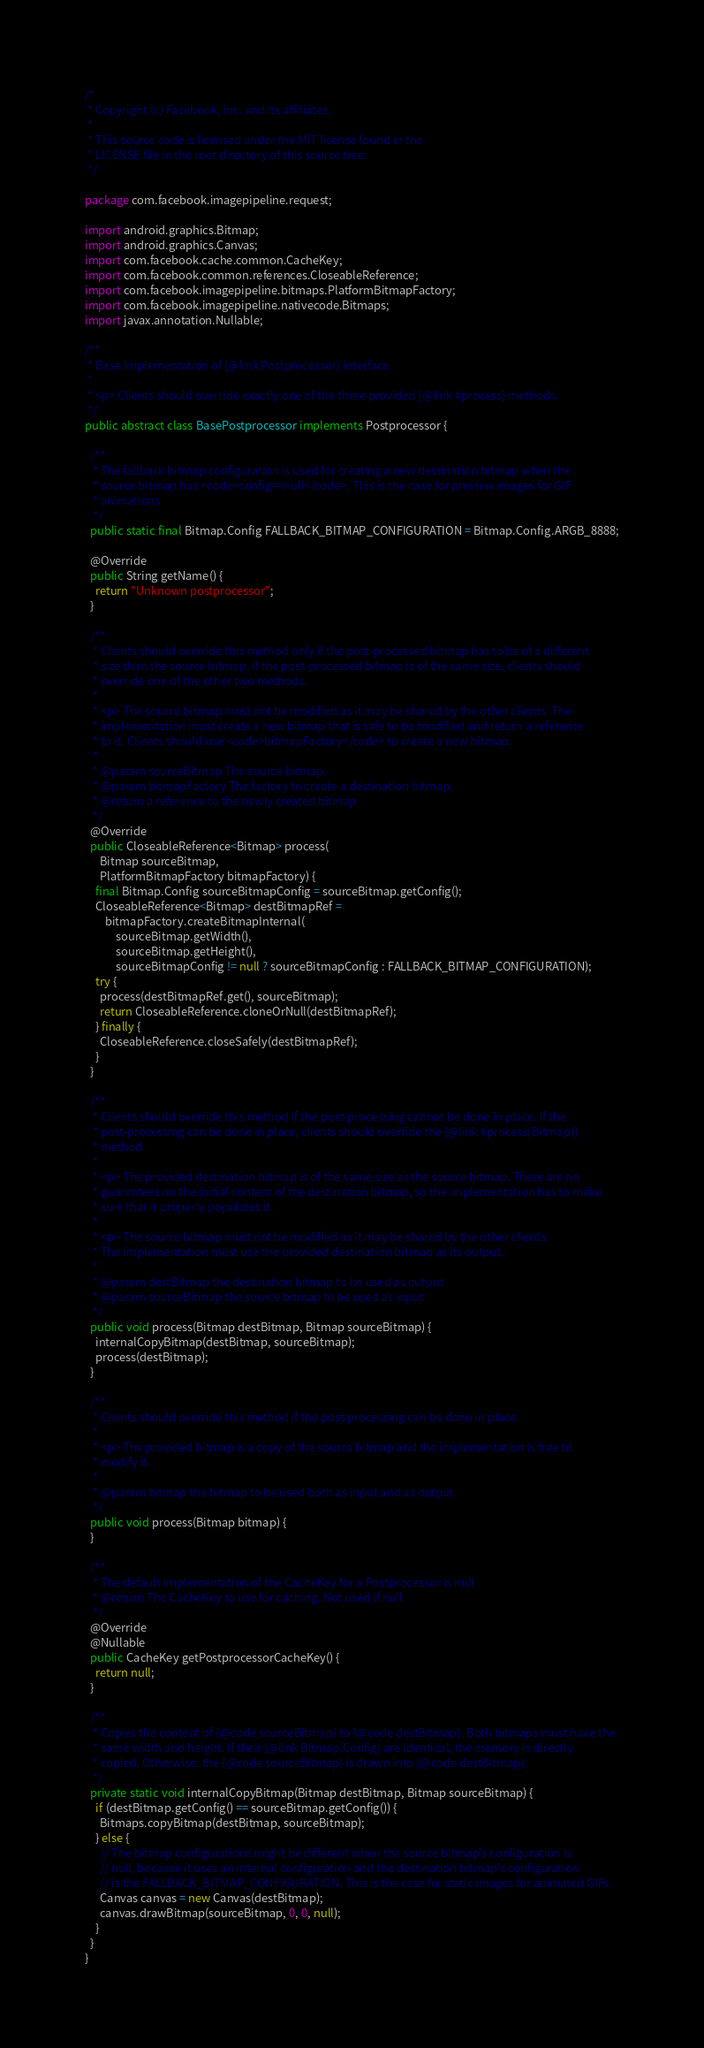<code> <loc_0><loc_0><loc_500><loc_500><_Java_>/*
 * Copyright (c) Facebook, Inc. and its affiliates.
 *
 * This source code is licensed under the MIT license found in the
 * LICENSE file in the root directory of this source tree.
 */

package com.facebook.imagepipeline.request;

import android.graphics.Bitmap;
import android.graphics.Canvas;
import com.facebook.cache.common.CacheKey;
import com.facebook.common.references.CloseableReference;
import com.facebook.imagepipeline.bitmaps.PlatformBitmapFactory;
import com.facebook.imagepipeline.nativecode.Bitmaps;
import javax.annotation.Nullable;

/**
 * Base implementation of {@link Postprocessor} interface.
 *
 * <p> Clients should override exactly one of the three provided {@link #process} methods.
 */
public abstract class BasePostprocessor implements Postprocessor {

  /**
   * The fallback bitmap configuration is used for creating a new destination bitmap when the
   * source bitmap has <code>config==null</code>. This is the case for preview images for GIF
   * animations.
   */
  public static final Bitmap.Config FALLBACK_BITMAP_CONFIGURATION = Bitmap.Config.ARGB_8888;

  @Override
  public String getName() {
    return "Unknown postprocessor";
  }

  /**
   * Clients should override this method only if the post-processed bitmap has to be of a different
   * size than the source bitmap. If the post-processed bitmap is of the same size, clients should
   * override one of the other two methods.
   *
   * <p> The source bitmap must not be modified as it may be shared by the other clients. The
   * implementation must create a new bitmap that is safe to be modified and return a reference
   * to it. Clients should use <code>bitmapFactory</code> to create a new bitmap.
   *
   * @param sourceBitmap The source bitmap.
   * @param bitmapFactory The factory to create a destination bitmap.
   * @return a reference to the newly created bitmap
   */
  @Override
  public CloseableReference<Bitmap> process(
      Bitmap sourceBitmap,
      PlatformBitmapFactory bitmapFactory) {
    final Bitmap.Config sourceBitmapConfig = sourceBitmap.getConfig();
    CloseableReference<Bitmap> destBitmapRef =
        bitmapFactory.createBitmapInternal(
            sourceBitmap.getWidth(),
            sourceBitmap.getHeight(),
            sourceBitmapConfig != null ? sourceBitmapConfig : FALLBACK_BITMAP_CONFIGURATION);
    try {
      process(destBitmapRef.get(), sourceBitmap);
      return CloseableReference.cloneOrNull(destBitmapRef);
    } finally {
      CloseableReference.closeSafely(destBitmapRef);
    }
  }

  /**
   * Clients should override this method if the post-processing cannot be done in place. If the
   * post-processing can be done in place, clients should override the {@link #process(Bitmap)}
   * method.
   *
   * <p> The provided destination bitmap is of the same size as the source bitmap. There are no
   * guarantees on the initial content of the destination bitmap, so the implementation has to make
   * sure that it properly populates it.
   *
   * <p> The source bitmap must not be modified as it may be shared by the other clients.
   * The implementation must use the provided destination bitmap as its output.
   *
   * @param destBitmap the destination bitmap to be used as output
   * @param sourceBitmap the source bitmap to be used as input
   */
  public void process(Bitmap destBitmap, Bitmap sourceBitmap) {
    internalCopyBitmap(destBitmap, sourceBitmap);
    process(destBitmap);
  }

  /**
   * Clients should override this method if the post-processing can be done in place.
   *
   * <p> The provided bitmap is a copy of the source bitmap and the implementation is free to
   * modify it.
   *
   * @param bitmap the bitmap to be used both as input and as output
   */
  public void process(Bitmap bitmap) {
  }

  /**
   * The default implementation of the CacheKey for a Postprocessor is null
   * @return The CacheKey to use for caching. Not used if null
   */
  @Override
  @Nullable
  public CacheKey getPostprocessorCacheKey() {
    return null;
  }

  /**
   * Copies the content of {@code sourceBitmap} to {@code destBitmap}. Both bitmaps must have the
   * same width and height. If their {@link Bitmap.Config} are identical, the memory is directly
   * copied. Otherwise, the {@code sourceBitmap} is drawn into {@code destBitmap}.
   */
  private static void internalCopyBitmap(Bitmap destBitmap, Bitmap sourceBitmap) {
    if (destBitmap.getConfig() == sourceBitmap.getConfig()) {
      Bitmaps.copyBitmap(destBitmap, sourceBitmap);
    } else {
      // The bitmap configurations might be different when the source bitmap's configuration is
      // null, because it uses an internal configuration and the destination bitmap's configuration
      // is the FALLBACK_BITMAP_CONFIGURATION. This is the case for static images for animated GIFs.
      Canvas canvas = new Canvas(destBitmap);
      canvas.drawBitmap(sourceBitmap, 0, 0, null);
    }
  }
}
</code> 